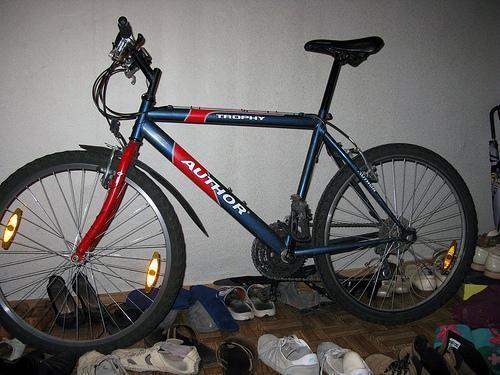How many wheels does this have?
Give a very brief answer. 2. How many reflectors can be seen?
Give a very brief answer. 3. 